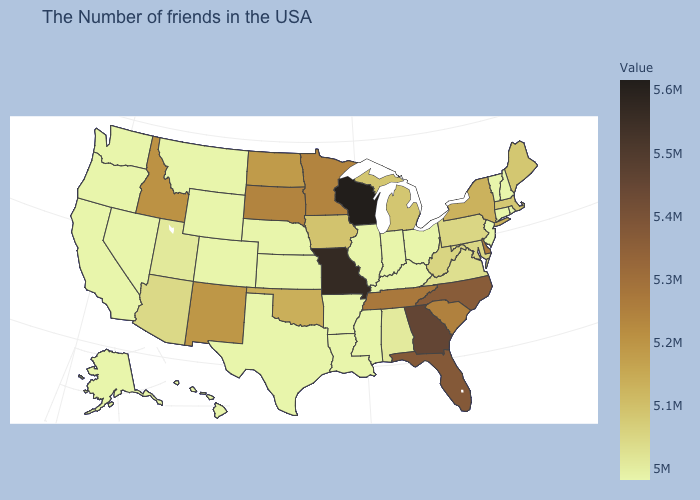Among the states that border Oklahoma , which have the highest value?
Short answer required. Missouri. Does the map have missing data?
Give a very brief answer. No. Among the states that border Virginia , does North Carolina have the highest value?
Concise answer only. Yes. Does the map have missing data?
Give a very brief answer. No. Does Mississippi have the lowest value in the USA?
Give a very brief answer. Yes. Among the states that border Oregon , does Idaho have the highest value?
Keep it brief. Yes. 